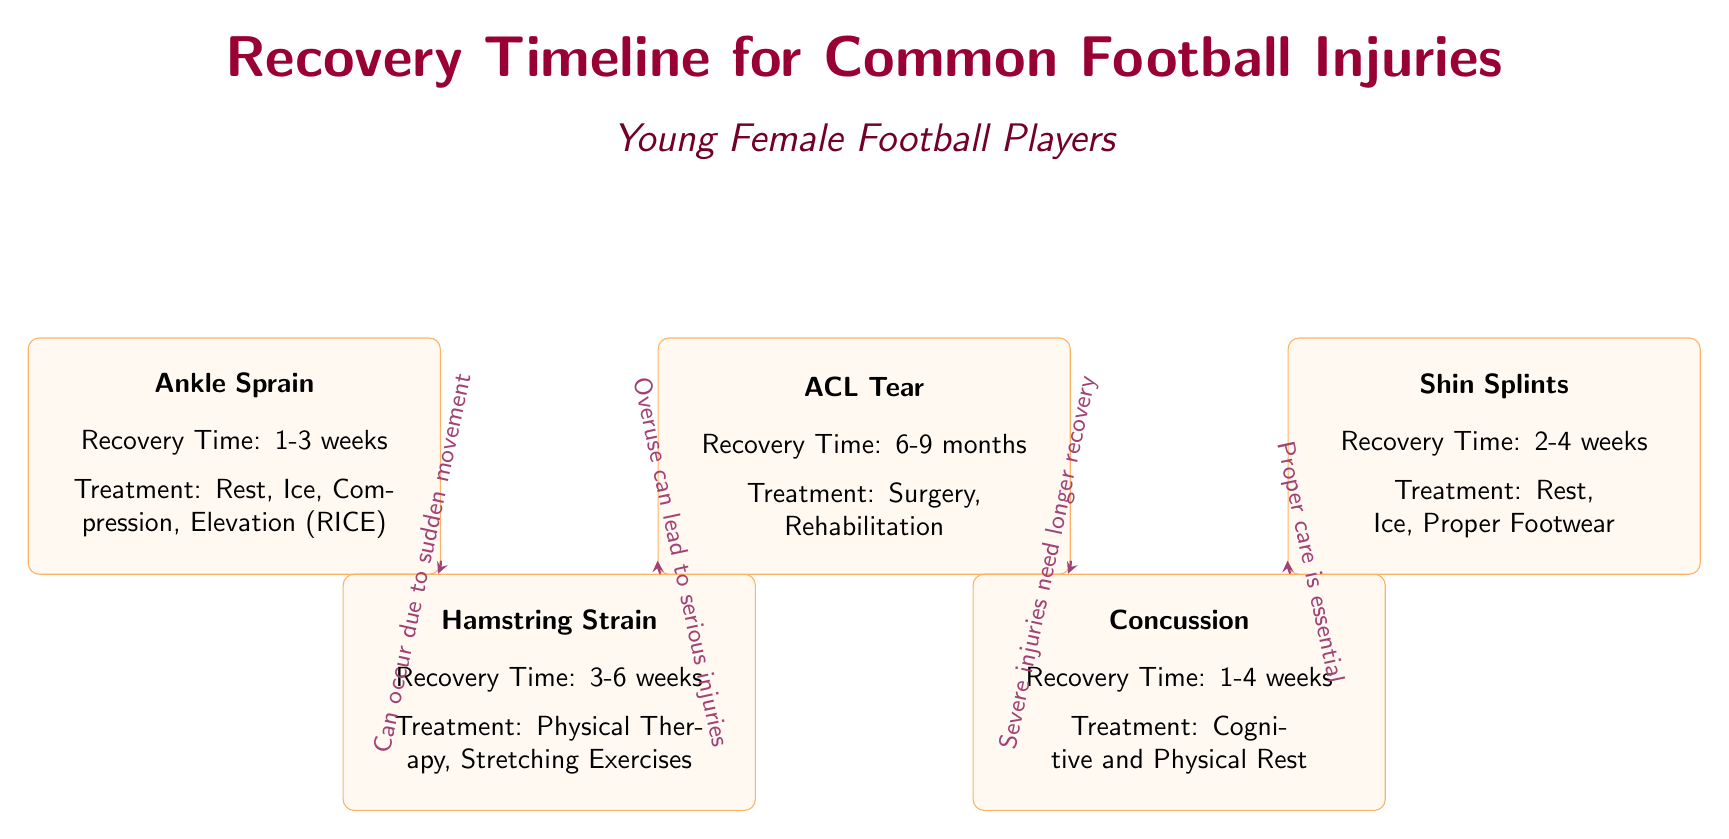What is the recovery time for an ankle sprain? The diagram states that an ankle sprain has a recovery time of 1-3 weeks.
Answer: 1-3 weeks How many injuries are listed in the diagram? The diagram lists five injuries: Ankle Sprain, Hamstring Strain, ACL Tear, Concussion, and Shin Splints.
Answer: 5 What treatment is recommended for a hamstring strain? The diagram indicates that the recommended treatment for a hamstring strain includes Physical Therapy and Stretching Exercises.
Answer: Physical Therapy, Stretching Exercises Which injury has the longest recovery time? By comparing the recovery times listed, the ACL Tear has the longest recovery time of 6-9 months.
Answer: ACL Tear What is the common treatment for shin splints? According to the diagram, the common treatment for shin splints is Rest, Ice, and Proper Footwear.
Answer: Rest, Ice, Proper Footwear How does an ankle sprain relate to a hamstring strain? The diagram shows an arrow labeled "Can occur due to sudden movement" leading from Ankle Sprain to Hamstring Strain, indicating that movement causing one injury could result in another.
Answer: Can occur due to sudden movement What recovery time range is given for a concussion? The recovery time for a concussion as stated in the diagram is 1-4 weeks.
Answer: 1-4 weeks What does the diagram suggest about treatment after an ACL tear? The treatment for an ACL Tear includes Surgery and Rehabilitation, as indicated in the diagram.
Answer: Surgery, Rehabilitation What is the treatment method for a concussion? The diagram specifies Cognitive and Physical Rest as the treatment for a concussion.
Answer: Cognitive and Physical Rest 